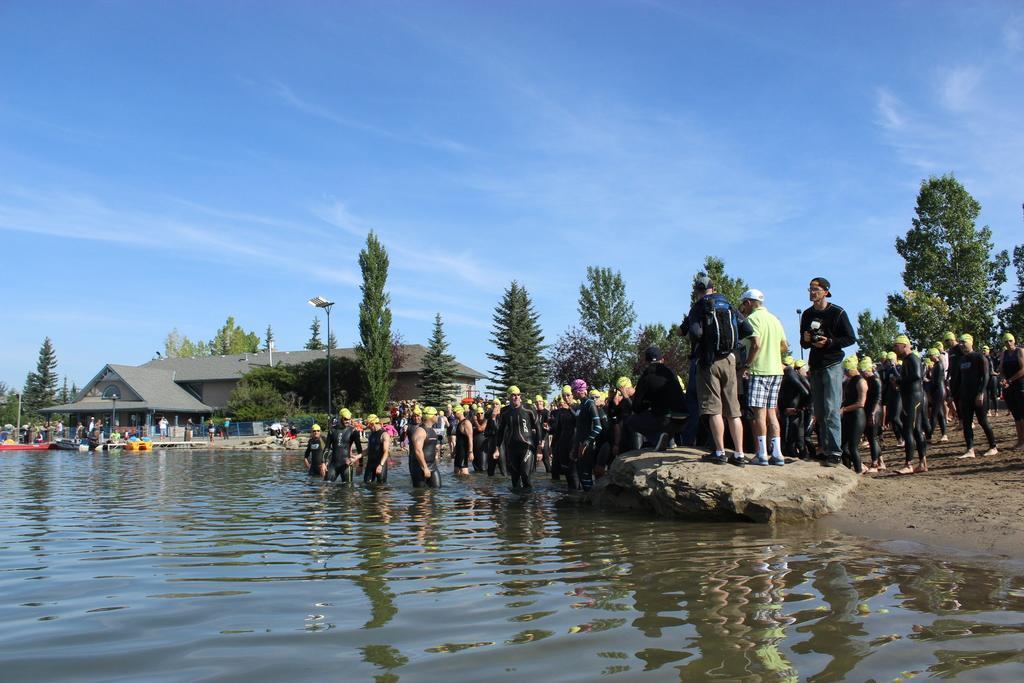In one or two sentences, can you explain what this image depicts? In the foreground of the picture there are people, sand, rock and water. In the center the picture there are trees, light, building, boats and people. Sky is not clear and it is sunny. 